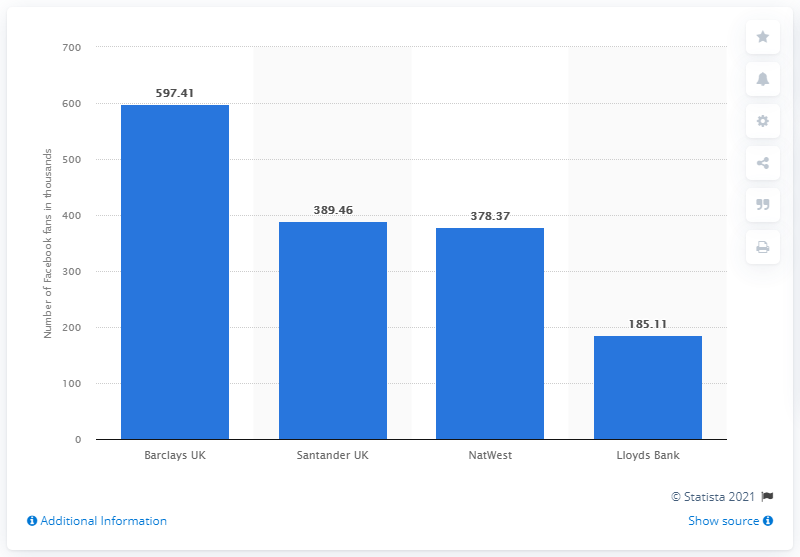Indicate a few pertinent items in this graphic. Santander UK was the second most popular bank in the UK. NatWest was the third most popular bank in the UK. Barclays UK was the most popular bank on the UK market among Facebook fans. 